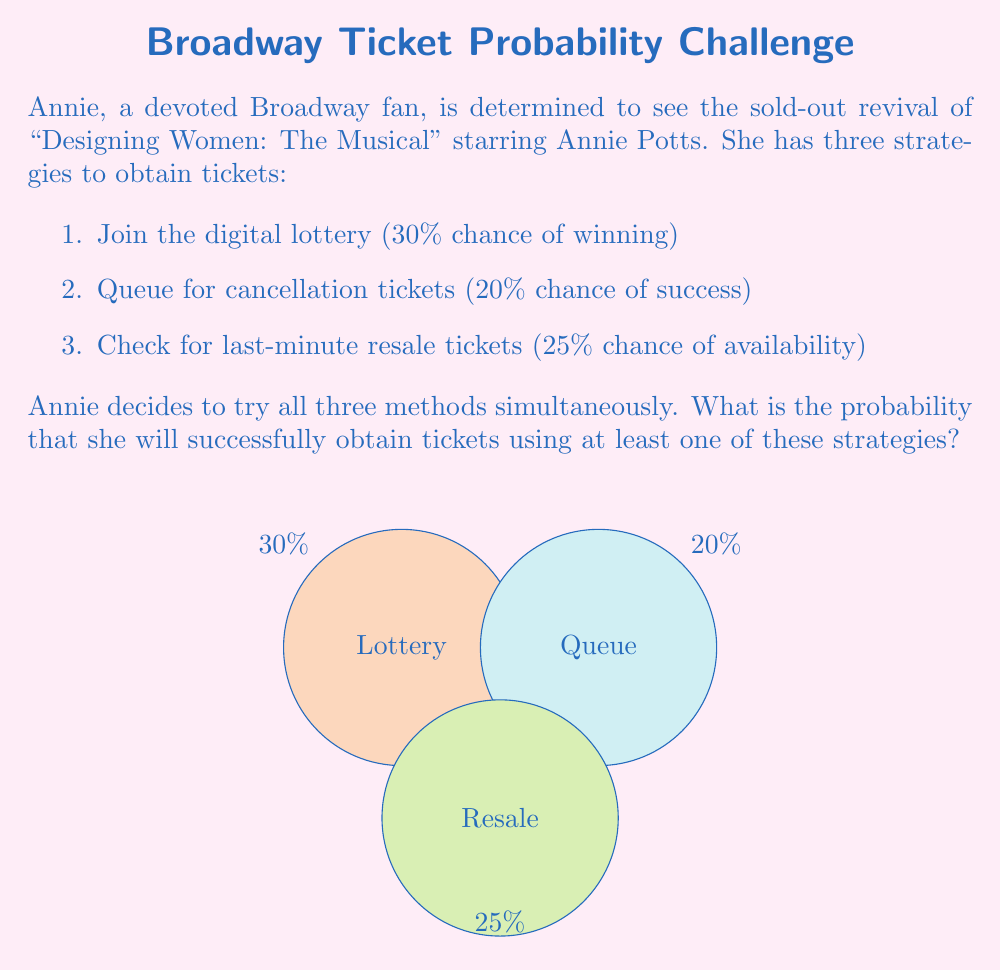Could you help me with this problem? To solve this problem, we'll use the concept of complementary probability and the multiplication rule for independent events.

Step 1: Calculate the probability of not getting tickets through each method.
- Lottery: $P(\text{not winning lottery}) = 1 - 0.30 = 0.70$
- Queue: $P(\text{not getting cancellation tickets}) = 1 - 0.20 = 0.80$
- Resale: $P(\text{not finding resale tickets}) = 1 - 0.25 = 0.75$

Step 2: Calculate the probability of not getting tickets through any method.
Since the events are independent, we multiply these probabilities:

$P(\text{no tickets}) = 0.70 \times 0.80 \times 0.75 = 0.42$

Step 3: Calculate the probability of getting tickets through at least one method.
This is the complement of not getting tickets through any method:

$P(\text{at least one success}) = 1 - P(\text{no tickets}) = 1 - 0.42 = 0.58$

Step 4: Convert to a percentage.
$0.58 \times 100\% = 58\%$

Therefore, Annie has a 58% chance of obtaining tickets using at least one of these strategies.
Answer: 58% 